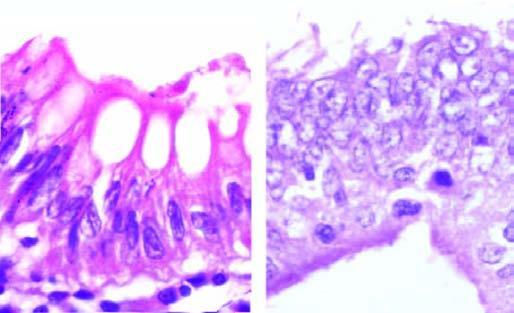s the kidney contrasted with normal basal polarity in columnar epithelium?
Answer the question using a single word or phrase. No 